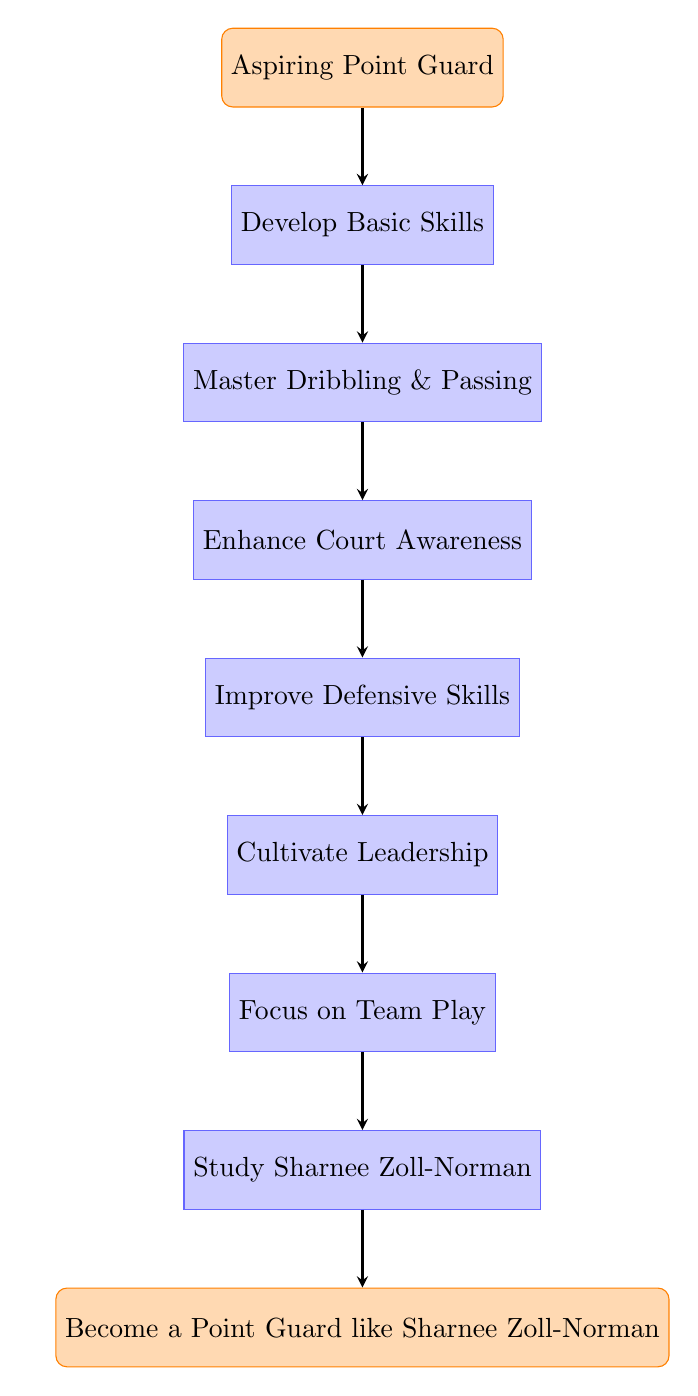What is the first step to become a point guard? The first step in the flow chart is labeled "Aspiring Point Guard." This is the starting point of the progression.
Answer: Aspiring Point Guard Which skill comes after developing basic skills? Looking at the progression in the flow chart, "Master Dribbling & Passing" directly follows "Develop Basic Skills."
Answer: Master Dribbling & Passing How many total skills need to be developed before studying Sharnee Zoll-Norman? To determine the total skills before "Study Sharnee Zoll-Norman," we can count the nodes from "Develop Basic Skills" to "Focus on Team Play," which totals six nodes.
Answer: 6 What is the output of reaching the last node? The last node in the flow chart is "Become a Point Guard like Sharnee Zoll-Norman," indicating that this is the ultimate goal of the progression.
Answer: Become a Point Guard like Sharnee Zoll-Norman What is the relationship between 'Cultivate Leadership' and 'Focus on Team Play'? "Cultivate Leadership" is a step that feeds into "Focus on Team Play." Thus, focusing on team play comes after cultivating leadership.
Answer: Cultivate Leadership → Focus on Team Play What is the last step before the ultimate goal? The last node before reaching "Become a Point Guard like Sharnee Zoll-Norman" is "Study Sharnee Zoll-Norman." This indicates that studying her is a culmination of the previous skills.
Answer: Study Sharnee Zoll-Norman Which process emphasizes teamwork? The process labeled "Focus on Team Play" emphasizes the importance of teamwork in becoming a point guard, highlighting that players must work well with their teammates.
Answer: Focus on Team Play 